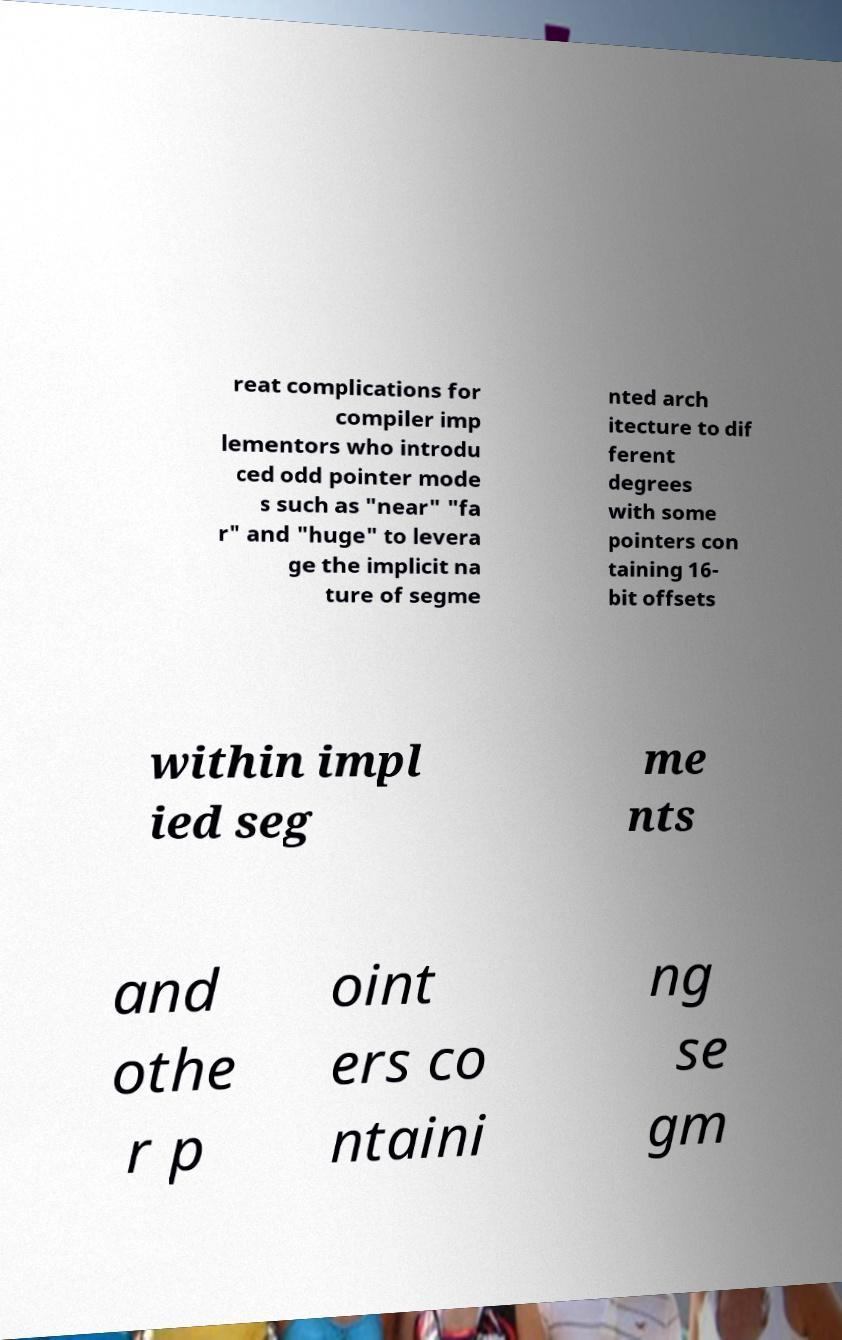Could you assist in decoding the text presented in this image and type it out clearly? reat complications for compiler imp lementors who introdu ced odd pointer mode s such as "near" "fa r" and "huge" to levera ge the implicit na ture of segme nted arch itecture to dif ferent degrees with some pointers con taining 16- bit offsets within impl ied seg me nts and othe r p oint ers co ntaini ng se gm 